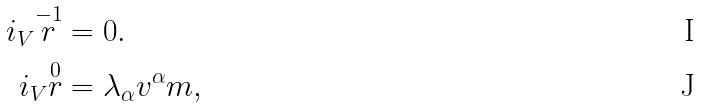<formula> <loc_0><loc_0><loc_500><loc_500>i _ { V } \overset { - 1 } { r } & = 0 . \\ i _ { V } \overset { 0 } { r } & = \lambda _ { \alpha } v ^ { \alpha } m ,</formula> 